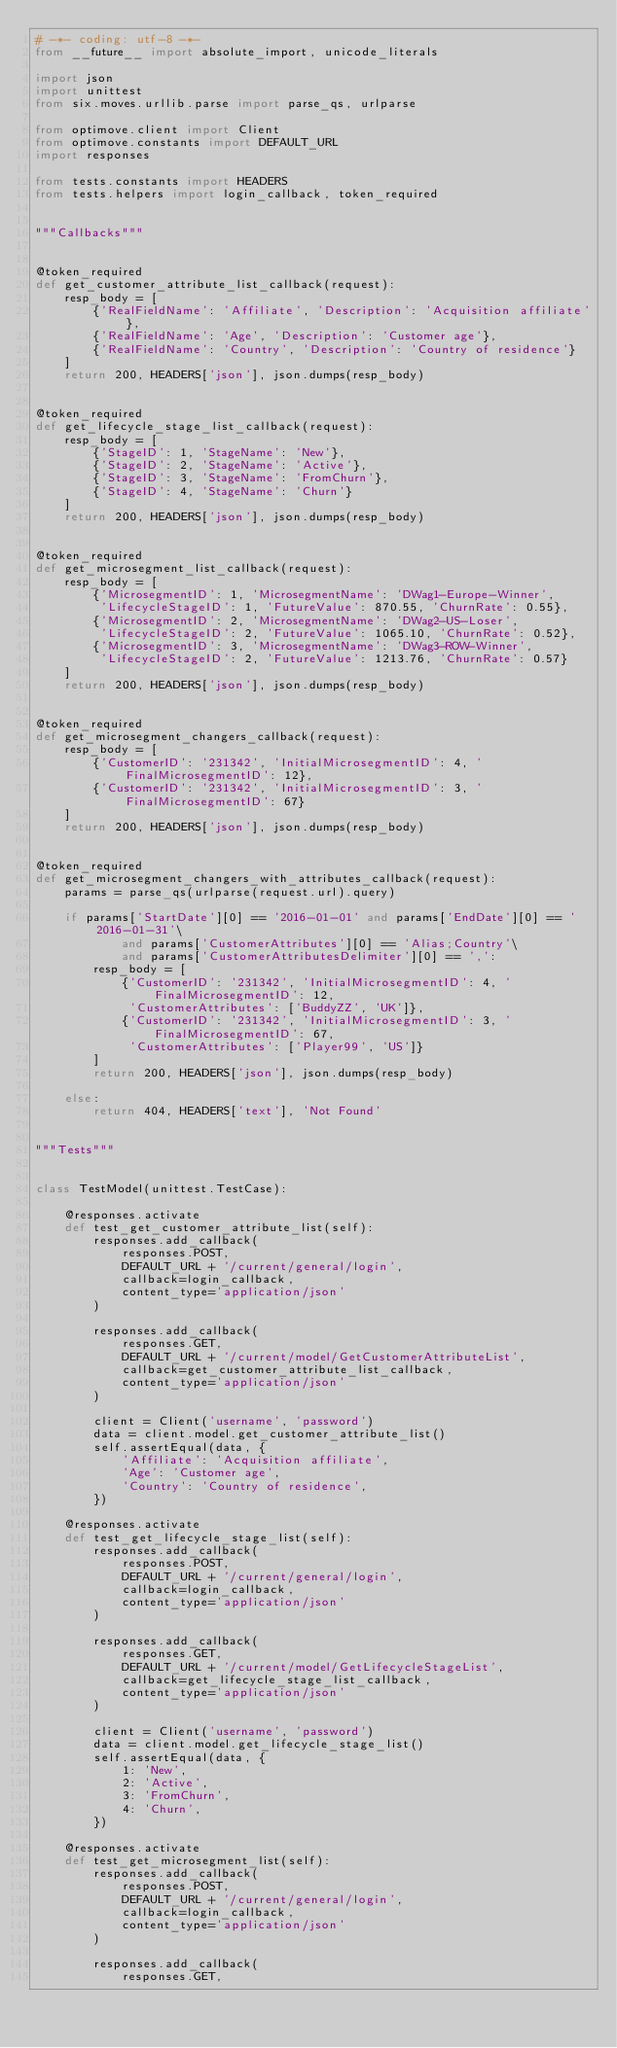Convert code to text. <code><loc_0><loc_0><loc_500><loc_500><_Python_># -*- coding: utf-8 -*-
from __future__ import absolute_import, unicode_literals

import json
import unittest
from six.moves.urllib.parse import parse_qs, urlparse

from optimove.client import Client
from optimove.constants import DEFAULT_URL
import responses

from tests.constants import HEADERS
from tests.helpers import login_callback, token_required


"""Callbacks"""


@token_required
def get_customer_attribute_list_callback(request):
    resp_body = [
        {'RealFieldName': 'Affiliate', 'Description': 'Acquisition affiliate'},
        {'RealFieldName': 'Age', 'Description': 'Customer age'},
        {'RealFieldName': 'Country', 'Description': 'Country of residence'}
    ]
    return 200, HEADERS['json'], json.dumps(resp_body)


@token_required
def get_lifecycle_stage_list_callback(request):
    resp_body = [
        {'StageID': 1, 'StageName': 'New'},
        {'StageID': 2, 'StageName': 'Active'},
        {'StageID': 3, 'StageName': 'FromChurn'},
        {'StageID': 4, 'StageName': 'Churn'}
    ]
    return 200, HEADERS['json'], json.dumps(resp_body)


@token_required
def get_microsegment_list_callback(request):
    resp_body = [
        {'MicrosegmentID': 1, 'MicrosegmentName': 'DWag1-Europe-Winner',
         'LifecycleStageID': 1, 'FutureValue': 870.55, 'ChurnRate': 0.55},
        {'MicrosegmentID': 2, 'MicrosegmentName': 'DWag2-US-Loser',
         'LifecycleStageID': 2, 'FutureValue': 1065.10, 'ChurnRate': 0.52},
        {'MicrosegmentID': 3, 'MicrosegmentName': 'DWag3-ROW-Winner',
         'LifecycleStageID': 2, 'FutureValue': 1213.76, 'ChurnRate': 0.57}
    ]
    return 200, HEADERS['json'], json.dumps(resp_body)


@token_required
def get_microsegment_changers_callback(request):
    resp_body = [
        {'CustomerID': '231342', 'InitialMicrosegmentID': 4, 'FinalMicrosegmentID': 12},
        {'CustomerID': '231342', 'InitialMicrosegmentID': 3, 'FinalMicrosegmentID': 67}
    ]
    return 200, HEADERS['json'], json.dumps(resp_body)


@token_required
def get_microsegment_changers_with_attributes_callback(request):
    params = parse_qs(urlparse(request.url).query)

    if params['StartDate'][0] == '2016-01-01' and params['EndDate'][0] == '2016-01-31'\
            and params['CustomerAttributes'][0] == 'Alias;Country'\
            and params['CustomerAttributesDelimiter'][0] == ',':
        resp_body = [
            {'CustomerID': '231342', 'InitialMicrosegmentID': 4, 'FinalMicrosegmentID': 12,
             'CustomerAttributes': ['BuddyZZ', 'UK']},
            {'CustomerID': '231342', 'InitialMicrosegmentID': 3, 'FinalMicrosegmentID': 67,
             'CustomerAttributes': ['Player99', 'US']}
        ]
        return 200, HEADERS['json'], json.dumps(resp_body)

    else:
        return 404, HEADERS['text'], 'Not Found'


"""Tests"""


class TestModel(unittest.TestCase):

    @responses.activate
    def test_get_customer_attribute_list(self):
        responses.add_callback(
            responses.POST,
            DEFAULT_URL + '/current/general/login',
            callback=login_callback,
            content_type='application/json'
        )

        responses.add_callback(
            responses.GET,
            DEFAULT_URL + '/current/model/GetCustomerAttributeList',
            callback=get_customer_attribute_list_callback,
            content_type='application/json'
        )

        client = Client('username', 'password')
        data = client.model.get_customer_attribute_list()
        self.assertEqual(data, {
            'Affiliate': 'Acquisition affiliate',
            'Age': 'Customer age',
            'Country': 'Country of residence',
        })

    @responses.activate
    def test_get_lifecycle_stage_list(self):
        responses.add_callback(
            responses.POST,
            DEFAULT_URL + '/current/general/login',
            callback=login_callback,
            content_type='application/json'
        )

        responses.add_callback(
            responses.GET,
            DEFAULT_URL + '/current/model/GetLifecycleStageList',
            callback=get_lifecycle_stage_list_callback,
            content_type='application/json'
        )

        client = Client('username', 'password')
        data = client.model.get_lifecycle_stage_list()
        self.assertEqual(data, {
            1: 'New',
            2: 'Active',
            3: 'FromChurn',
            4: 'Churn',
        })

    @responses.activate
    def test_get_microsegment_list(self):
        responses.add_callback(
            responses.POST,
            DEFAULT_URL + '/current/general/login',
            callback=login_callback,
            content_type='application/json'
        )

        responses.add_callback(
            responses.GET,</code> 